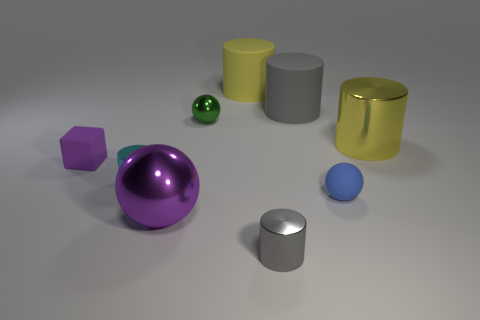Are there any other things that have the same shape as the tiny cyan object?
Make the answer very short. Yes. Is the size of the blue ball the same as the purple shiny object?
Your answer should be very brief. No. What material is the tiny cylinder that is on the right side of the big yellow cylinder that is on the left side of the shiny cylinder that is behind the small cyan cylinder made of?
Your response must be concise. Metal. Are there the same number of rubber cubes on the right side of the big sphere and gray cylinders?
Your answer should be compact. No. Are there any other things that have the same size as the purple metal object?
Keep it short and to the point. Yes. How many objects are either gray cylinders or large yellow matte cylinders?
Your response must be concise. 3. What shape is the yellow object that is made of the same material as the large gray object?
Provide a short and direct response. Cylinder. There is a gray cylinder that is in front of the gray cylinder that is on the right side of the gray metallic cylinder; what is its size?
Offer a very short reply. Small. What number of big things are rubber blocks or cylinders?
Your answer should be very brief. 3. How many other things are there of the same color as the large shiny sphere?
Your answer should be compact. 1. 